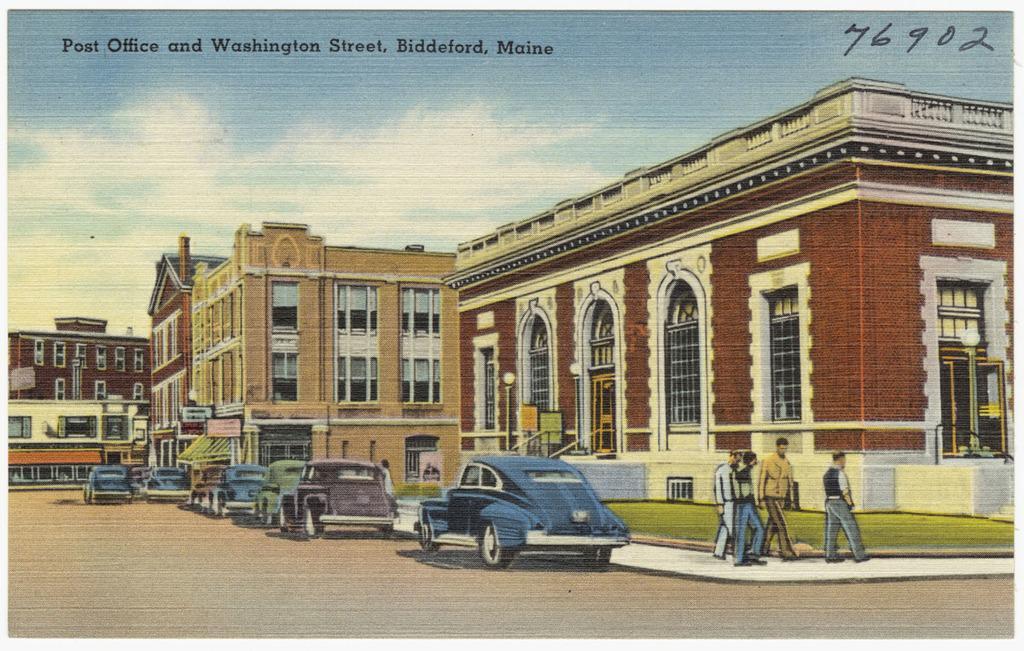Please provide a concise description of this image. This image is a drawing. In this there are buildings. There are cars. There are people walking. There is road. There is some text at the top of the image. 